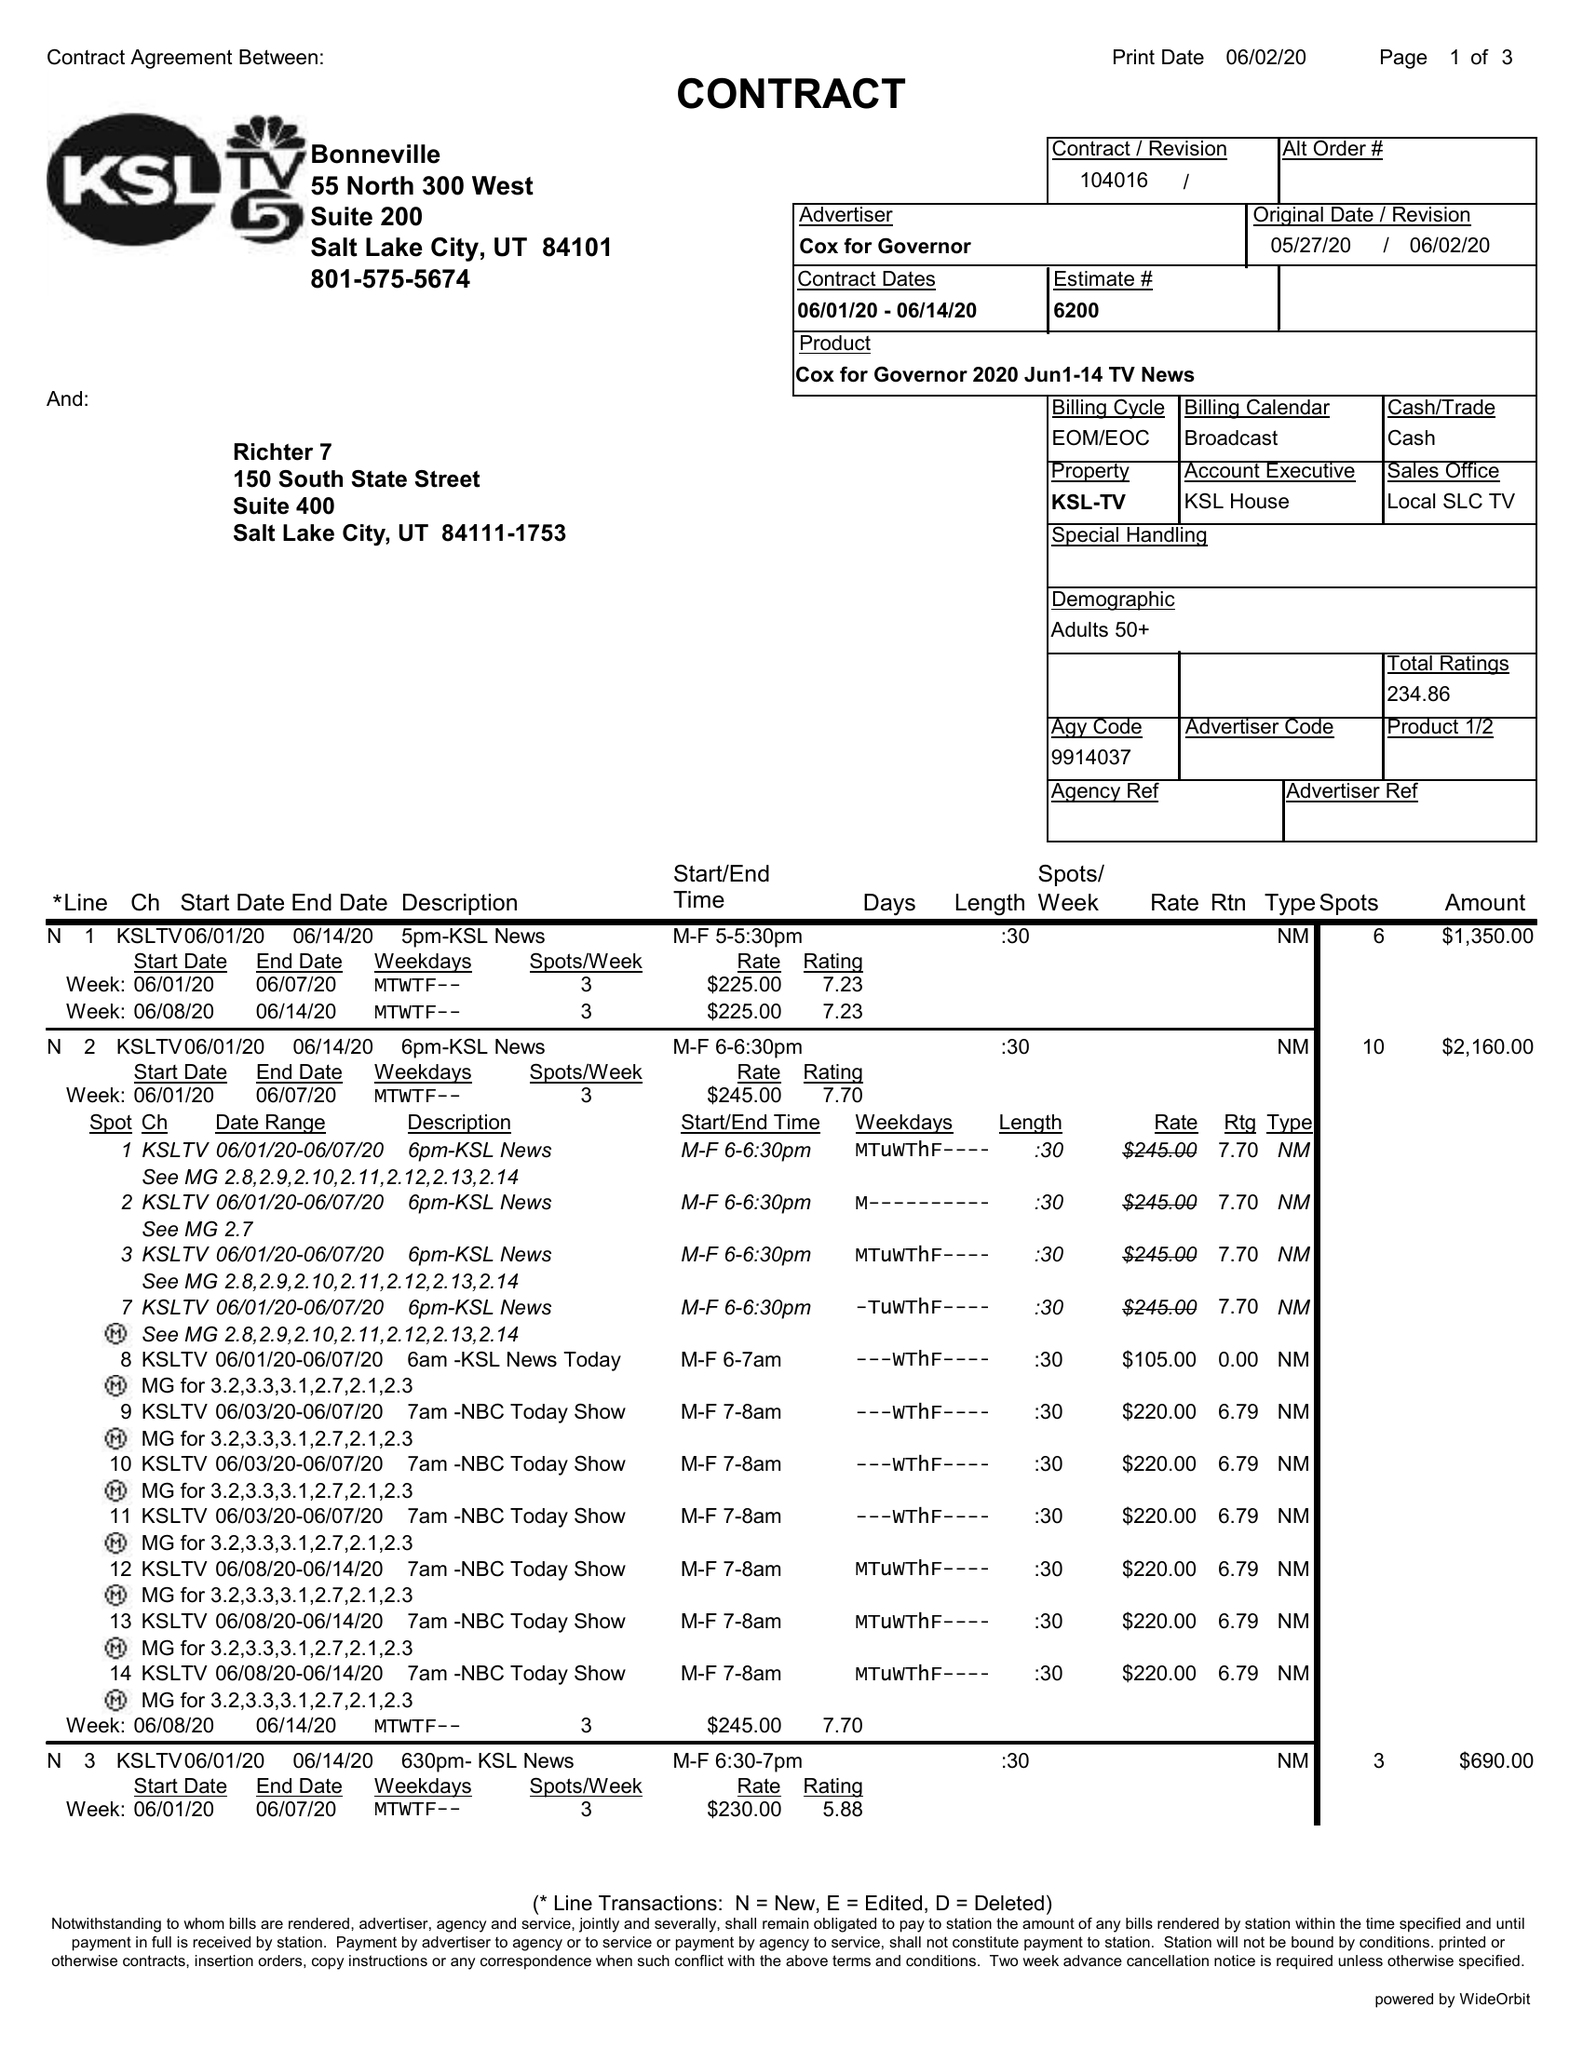What is the value for the flight_to?
Answer the question using a single word or phrase. 06/14/20 